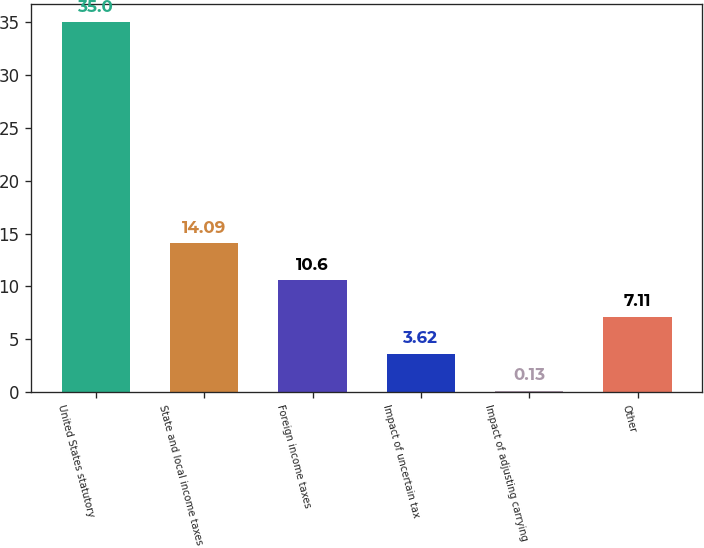Convert chart. <chart><loc_0><loc_0><loc_500><loc_500><bar_chart><fcel>United States statutory<fcel>State and local income taxes<fcel>Foreign income taxes<fcel>Impact of uncertain tax<fcel>Impact of adjusting carrying<fcel>Other<nl><fcel>35<fcel>14.09<fcel>10.6<fcel>3.62<fcel>0.13<fcel>7.11<nl></chart> 